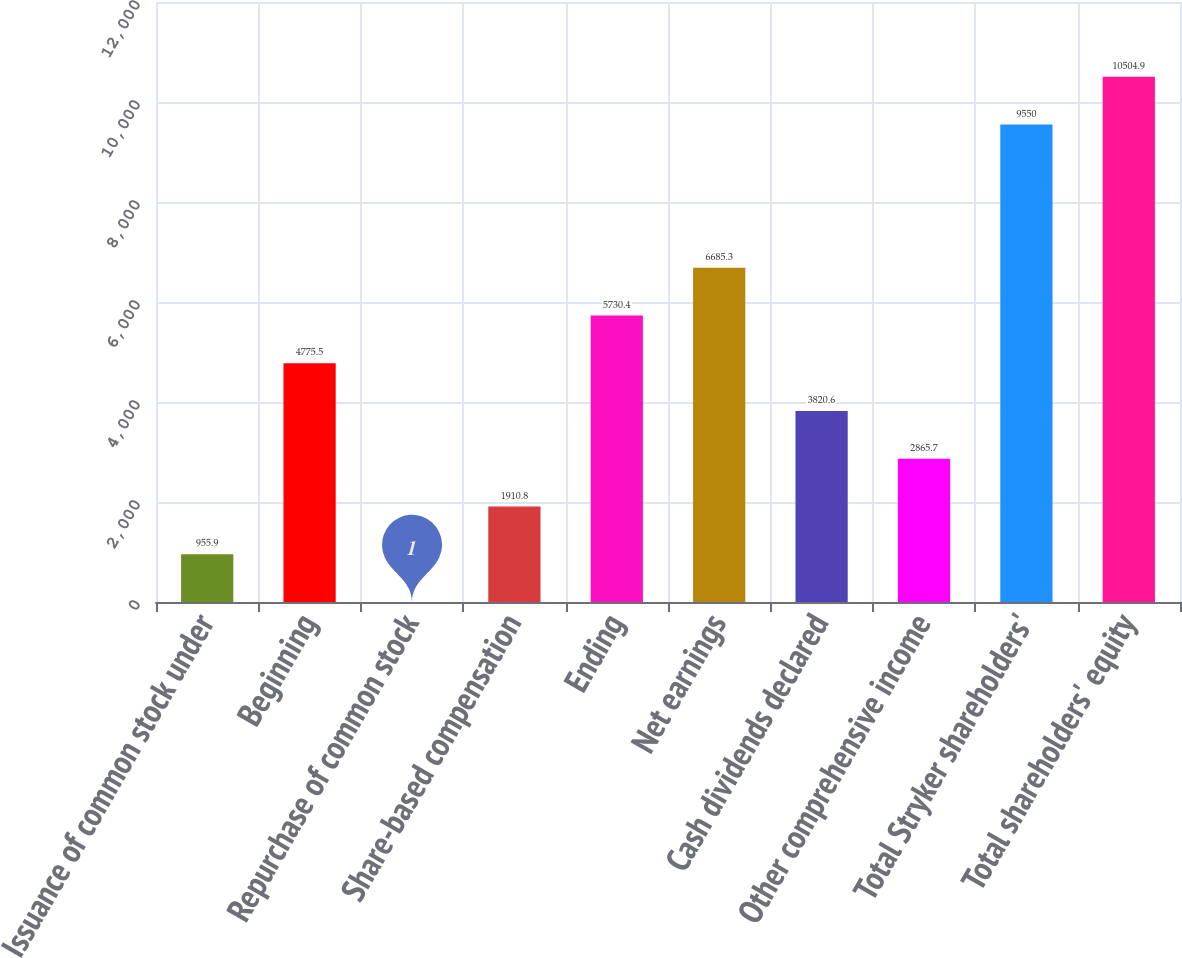Convert chart. <chart><loc_0><loc_0><loc_500><loc_500><bar_chart><fcel>Issuance of common stock under<fcel>Beginning<fcel>Repurchase of common stock<fcel>Share-based compensation<fcel>Ending<fcel>Net earnings<fcel>Cash dividends declared<fcel>Other comprehensive income<fcel>Total Stryker shareholders'<fcel>Total shareholders' equity<nl><fcel>955.9<fcel>4775.5<fcel>1<fcel>1910.8<fcel>5730.4<fcel>6685.3<fcel>3820.6<fcel>2865.7<fcel>9550<fcel>10504.9<nl></chart> 